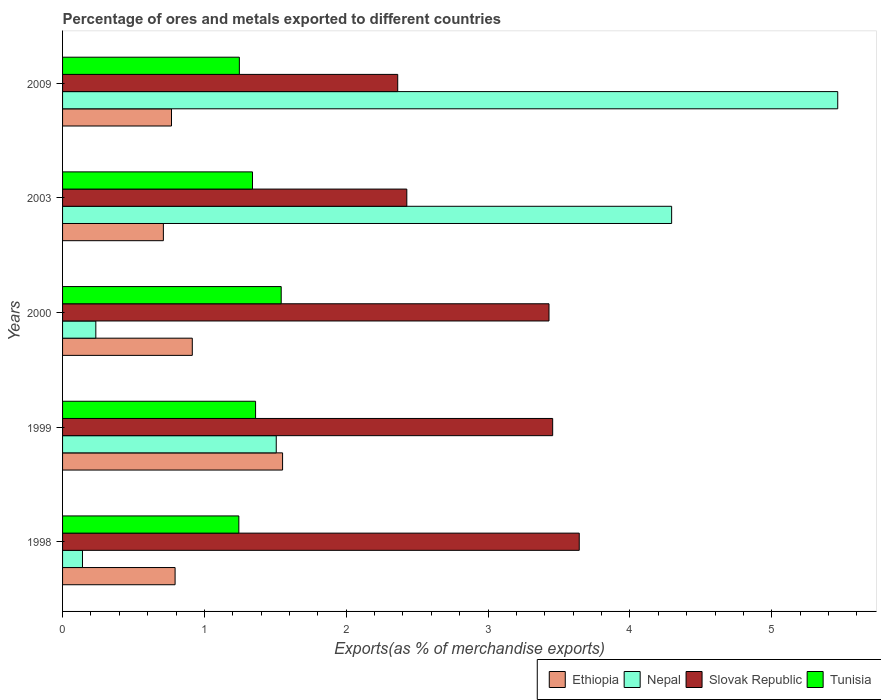How many different coloured bars are there?
Provide a short and direct response. 4. How many groups of bars are there?
Keep it short and to the point. 5. Are the number of bars per tick equal to the number of legend labels?
Ensure brevity in your answer.  Yes. Are the number of bars on each tick of the Y-axis equal?
Provide a succinct answer. Yes. How many bars are there on the 4th tick from the bottom?
Give a very brief answer. 4. In how many cases, is the number of bars for a given year not equal to the number of legend labels?
Provide a succinct answer. 0. What is the percentage of exports to different countries in Nepal in 2003?
Your response must be concise. 4.29. Across all years, what is the maximum percentage of exports to different countries in Ethiopia?
Your response must be concise. 1.55. Across all years, what is the minimum percentage of exports to different countries in Ethiopia?
Your answer should be compact. 0.71. What is the total percentage of exports to different countries in Nepal in the graph?
Provide a succinct answer. 11.64. What is the difference between the percentage of exports to different countries in Ethiopia in 1999 and that in 2003?
Make the answer very short. 0.84. What is the difference between the percentage of exports to different countries in Tunisia in 2009 and the percentage of exports to different countries in Nepal in 1998?
Your answer should be very brief. 1.11. What is the average percentage of exports to different countries in Tunisia per year?
Provide a succinct answer. 1.35. In the year 1998, what is the difference between the percentage of exports to different countries in Nepal and percentage of exports to different countries in Slovak Republic?
Keep it short and to the point. -3.5. What is the ratio of the percentage of exports to different countries in Tunisia in 1999 to that in 2000?
Offer a terse response. 0.88. Is the percentage of exports to different countries in Slovak Republic in 2003 less than that in 2009?
Provide a succinct answer. No. What is the difference between the highest and the second highest percentage of exports to different countries in Tunisia?
Your response must be concise. 0.18. What is the difference between the highest and the lowest percentage of exports to different countries in Tunisia?
Your answer should be very brief. 0.3. What does the 4th bar from the top in 2000 represents?
Make the answer very short. Ethiopia. What does the 4th bar from the bottom in 2003 represents?
Provide a succinct answer. Tunisia. Is it the case that in every year, the sum of the percentage of exports to different countries in Nepal and percentage of exports to different countries in Tunisia is greater than the percentage of exports to different countries in Ethiopia?
Your answer should be very brief. Yes. How many bars are there?
Ensure brevity in your answer.  20. How many years are there in the graph?
Keep it short and to the point. 5. Are the values on the major ticks of X-axis written in scientific E-notation?
Ensure brevity in your answer.  No. Does the graph contain any zero values?
Give a very brief answer. No. Where does the legend appear in the graph?
Ensure brevity in your answer.  Bottom right. How many legend labels are there?
Your answer should be compact. 4. What is the title of the graph?
Give a very brief answer. Percentage of ores and metals exported to different countries. Does "Upper middle income" appear as one of the legend labels in the graph?
Offer a very short reply. No. What is the label or title of the X-axis?
Offer a terse response. Exports(as % of merchandise exports). What is the label or title of the Y-axis?
Give a very brief answer. Years. What is the Exports(as % of merchandise exports) of Ethiopia in 1998?
Provide a short and direct response. 0.79. What is the Exports(as % of merchandise exports) in Nepal in 1998?
Your response must be concise. 0.14. What is the Exports(as % of merchandise exports) in Slovak Republic in 1998?
Offer a very short reply. 3.64. What is the Exports(as % of merchandise exports) of Tunisia in 1998?
Give a very brief answer. 1.24. What is the Exports(as % of merchandise exports) in Ethiopia in 1999?
Provide a short and direct response. 1.55. What is the Exports(as % of merchandise exports) in Nepal in 1999?
Keep it short and to the point. 1.51. What is the Exports(as % of merchandise exports) in Slovak Republic in 1999?
Provide a succinct answer. 3.46. What is the Exports(as % of merchandise exports) in Tunisia in 1999?
Ensure brevity in your answer.  1.36. What is the Exports(as % of merchandise exports) in Ethiopia in 2000?
Your answer should be very brief. 0.91. What is the Exports(as % of merchandise exports) of Nepal in 2000?
Keep it short and to the point. 0.23. What is the Exports(as % of merchandise exports) in Slovak Republic in 2000?
Your answer should be compact. 3.43. What is the Exports(as % of merchandise exports) of Tunisia in 2000?
Your answer should be very brief. 1.54. What is the Exports(as % of merchandise exports) of Ethiopia in 2003?
Offer a very short reply. 0.71. What is the Exports(as % of merchandise exports) in Nepal in 2003?
Your answer should be compact. 4.29. What is the Exports(as % of merchandise exports) in Slovak Republic in 2003?
Your answer should be very brief. 2.43. What is the Exports(as % of merchandise exports) in Tunisia in 2003?
Make the answer very short. 1.34. What is the Exports(as % of merchandise exports) of Ethiopia in 2009?
Ensure brevity in your answer.  0.77. What is the Exports(as % of merchandise exports) of Nepal in 2009?
Ensure brevity in your answer.  5.47. What is the Exports(as % of merchandise exports) of Slovak Republic in 2009?
Give a very brief answer. 2.36. What is the Exports(as % of merchandise exports) in Tunisia in 2009?
Your answer should be compact. 1.25. Across all years, what is the maximum Exports(as % of merchandise exports) in Ethiopia?
Provide a succinct answer. 1.55. Across all years, what is the maximum Exports(as % of merchandise exports) in Nepal?
Your response must be concise. 5.47. Across all years, what is the maximum Exports(as % of merchandise exports) of Slovak Republic?
Your answer should be compact. 3.64. Across all years, what is the maximum Exports(as % of merchandise exports) in Tunisia?
Provide a short and direct response. 1.54. Across all years, what is the minimum Exports(as % of merchandise exports) in Ethiopia?
Your answer should be compact. 0.71. Across all years, what is the minimum Exports(as % of merchandise exports) of Nepal?
Offer a very short reply. 0.14. Across all years, what is the minimum Exports(as % of merchandise exports) in Slovak Republic?
Provide a short and direct response. 2.36. Across all years, what is the minimum Exports(as % of merchandise exports) of Tunisia?
Keep it short and to the point. 1.24. What is the total Exports(as % of merchandise exports) in Ethiopia in the graph?
Provide a succinct answer. 4.74. What is the total Exports(as % of merchandise exports) of Nepal in the graph?
Keep it short and to the point. 11.64. What is the total Exports(as % of merchandise exports) of Slovak Republic in the graph?
Keep it short and to the point. 15.32. What is the total Exports(as % of merchandise exports) in Tunisia in the graph?
Your answer should be very brief. 6.73. What is the difference between the Exports(as % of merchandise exports) of Ethiopia in 1998 and that in 1999?
Offer a terse response. -0.76. What is the difference between the Exports(as % of merchandise exports) in Nepal in 1998 and that in 1999?
Provide a succinct answer. -1.37. What is the difference between the Exports(as % of merchandise exports) of Slovak Republic in 1998 and that in 1999?
Your answer should be very brief. 0.19. What is the difference between the Exports(as % of merchandise exports) in Tunisia in 1998 and that in 1999?
Make the answer very short. -0.12. What is the difference between the Exports(as % of merchandise exports) of Ethiopia in 1998 and that in 2000?
Your answer should be very brief. -0.12. What is the difference between the Exports(as % of merchandise exports) in Nepal in 1998 and that in 2000?
Provide a short and direct response. -0.09. What is the difference between the Exports(as % of merchandise exports) of Slovak Republic in 1998 and that in 2000?
Give a very brief answer. 0.21. What is the difference between the Exports(as % of merchandise exports) of Tunisia in 1998 and that in 2000?
Your answer should be very brief. -0.3. What is the difference between the Exports(as % of merchandise exports) of Ethiopia in 1998 and that in 2003?
Your answer should be compact. 0.08. What is the difference between the Exports(as % of merchandise exports) of Nepal in 1998 and that in 2003?
Keep it short and to the point. -4.15. What is the difference between the Exports(as % of merchandise exports) of Slovak Republic in 1998 and that in 2003?
Make the answer very short. 1.22. What is the difference between the Exports(as % of merchandise exports) of Tunisia in 1998 and that in 2003?
Your answer should be compact. -0.1. What is the difference between the Exports(as % of merchandise exports) in Ethiopia in 1998 and that in 2009?
Your response must be concise. 0.03. What is the difference between the Exports(as % of merchandise exports) of Nepal in 1998 and that in 2009?
Make the answer very short. -5.32. What is the difference between the Exports(as % of merchandise exports) in Slovak Republic in 1998 and that in 2009?
Provide a short and direct response. 1.28. What is the difference between the Exports(as % of merchandise exports) of Tunisia in 1998 and that in 2009?
Make the answer very short. -0. What is the difference between the Exports(as % of merchandise exports) of Ethiopia in 1999 and that in 2000?
Give a very brief answer. 0.64. What is the difference between the Exports(as % of merchandise exports) of Nepal in 1999 and that in 2000?
Provide a short and direct response. 1.27. What is the difference between the Exports(as % of merchandise exports) of Slovak Republic in 1999 and that in 2000?
Keep it short and to the point. 0.03. What is the difference between the Exports(as % of merchandise exports) of Tunisia in 1999 and that in 2000?
Ensure brevity in your answer.  -0.18. What is the difference between the Exports(as % of merchandise exports) of Ethiopia in 1999 and that in 2003?
Your response must be concise. 0.84. What is the difference between the Exports(as % of merchandise exports) in Nepal in 1999 and that in 2003?
Offer a terse response. -2.79. What is the difference between the Exports(as % of merchandise exports) in Slovak Republic in 1999 and that in 2003?
Ensure brevity in your answer.  1.03. What is the difference between the Exports(as % of merchandise exports) of Tunisia in 1999 and that in 2003?
Your answer should be very brief. 0.02. What is the difference between the Exports(as % of merchandise exports) in Ethiopia in 1999 and that in 2009?
Your answer should be compact. 0.78. What is the difference between the Exports(as % of merchandise exports) of Nepal in 1999 and that in 2009?
Your answer should be very brief. -3.96. What is the difference between the Exports(as % of merchandise exports) of Slovak Republic in 1999 and that in 2009?
Offer a very short reply. 1.09. What is the difference between the Exports(as % of merchandise exports) in Tunisia in 1999 and that in 2009?
Ensure brevity in your answer.  0.11. What is the difference between the Exports(as % of merchandise exports) of Ethiopia in 2000 and that in 2003?
Keep it short and to the point. 0.2. What is the difference between the Exports(as % of merchandise exports) in Nepal in 2000 and that in 2003?
Your answer should be compact. -4.06. What is the difference between the Exports(as % of merchandise exports) in Slovak Republic in 2000 and that in 2003?
Provide a succinct answer. 1. What is the difference between the Exports(as % of merchandise exports) of Tunisia in 2000 and that in 2003?
Give a very brief answer. 0.2. What is the difference between the Exports(as % of merchandise exports) in Ethiopia in 2000 and that in 2009?
Offer a very short reply. 0.15. What is the difference between the Exports(as % of merchandise exports) in Nepal in 2000 and that in 2009?
Keep it short and to the point. -5.23. What is the difference between the Exports(as % of merchandise exports) of Slovak Republic in 2000 and that in 2009?
Provide a succinct answer. 1.07. What is the difference between the Exports(as % of merchandise exports) in Tunisia in 2000 and that in 2009?
Provide a succinct answer. 0.3. What is the difference between the Exports(as % of merchandise exports) of Ethiopia in 2003 and that in 2009?
Offer a very short reply. -0.06. What is the difference between the Exports(as % of merchandise exports) in Nepal in 2003 and that in 2009?
Provide a succinct answer. -1.17. What is the difference between the Exports(as % of merchandise exports) of Slovak Republic in 2003 and that in 2009?
Provide a short and direct response. 0.06. What is the difference between the Exports(as % of merchandise exports) of Tunisia in 2003 and that in 2009?
Offer a terse response. 0.09. What is the difference between the Exports(as % of merchandise exports) of Ethiopia in 1998 and the Exports(as % of merchandise exports) of Nepal in 1999?
Offer a terse response. -0.71. What is the difference between the Exports(as % of merchandise exports) in Ethiopia in 1998 and the Exports(as % of merchandise exports) in Slovak Republic in 1999?
Your answer should be compact. -2.66. What is the difference between the Exports(as % of merchandise exports) of Ethiopia in 1998 and the Exports(as % of merchandise exports) of Tunisia in 1999?
Your response must be concise. -0.57. What is the difference between the Exports(as % of merchandise exports) in Nepal in 1998 and the Exports(as % of merchandise exports) in Slovak Republic in 1999?
Keep it short and to the point. -3.31. What is the difference between the Exports(as % of merchandise exports) in Nepal in 1998 and the Exports(as % of merchandise exports) in Tunisia in 1999?
Provide a succinct answer. -1.22. What is the difference between the Exports(as % of merchandise exports) of Slovak Republic in 1998 and the Exports(as % of merchandise exports) of Tunisia in 1999?
Keep it short and to the point. 2.28. What is the difference between the Exports(as % of merchandise exports) of Ethiopia in 1998 and the Exports(as % of merchandise exports) of Nepal in 2000?
Give a very brief answer. 0.56. What is the difference between the Exports(as % of merchandise exports) in Ethiopia in 1998 and the Exports(as % of merchandise exports) in Slovak Republic in 2000?
Provide a short and direct response. -2.64. What is the difference between the Exports(as % of merchandise exports) of Ethiopia in 1998 and the Exports(as % of merchandise exports) of Tunisia in 2000?
Provide a short and direct response. -0.75. What is the difference between the Exports(as % of merchandise exports) of Nepal in 1998 and the Exports(as % of merchandise exports) of Slovak Republic in 2000?
Provide a short and direct response. -3.29. What is the difference between the Exports(as % of merchandise exports) in Nepal in 1998 and the Exports(as % of merchandise exports) in Tunisia in 2000?
Your answer should be compact. -1.4. What is the difference between the Exports(as % of merchandise exports) of Slovak Republic in 1998 and the Exports(as % of merchandise exports) of Tunisia in 2000?
Offer a terse response. 2.1. What is the difference between the Exports(as % of merchandise exports) of Ethiopia in 1998 and the Exports(as % of merchandise exports) of Nepal in 2003?
Give a very brief answer. -3.5. What is the difference between the Exports(as % of merchandise exports) in Ethiopia in 1998 and the Exports(as % of merchandise exports) in Slovak Republic in 2003?
Your response must be concise. -1.63. What is the difference between the Exports(as % of merchandise exports) of Ethiopia in 1998 and the Exports(as % of merchandise exports) of Tunisia in 2003?
Provide a succinct answer. -0.55. What is the difference between the Exports(as % of merchandise exports) of Nepal in 1998 and the Exports(as % of merchandise exports) of Slovak Republic in 2003?
Give a very brief answer. -2.29. What is the difference between the Exports(as % of merchandise exports) in Nepal in 1998 and the Exports(as % of merchandise exports) in Tunisia in 2003?
Offer a terse response. -1.2. What is the difference between the Exports(as % of merchandise exports) of Slovak Republic in 1998 and the Exports(as % of merchandise exports) of Tunisia in 2003?
Give a very brief answer. 2.3. What is the difference between the Exports(as % of merchandise exports) in Ethiopia in 1998 and the Exports(as % of merchandise exports) in Nepal in 2009?
Provide a succinct answer. -4.67. What is the difference between the Exports(as % of merchandise exports) in Ethiopia in 1998 and the Exports(as % of merchandise exports) in Slovak Republic in 2009?
Keep it short and to the point. -1.57. What is the difference between the Exports(as % of merchandise exports) in Ethiopia in 1998 and the Exports(as % of merchandise exports) in Tunisia in 2009?
Your response must be concise. -0.45. What is the difference between the Exports(as % of merchandise exports) of Nepal in 1998 and the Exports(as % of merchandise exports) of Slovak Republic in 2009?
Provide a short and direct response. -2.22. What is the difference between the Exports(as % of merchandise exports) of Nepal in 1998 and the Exports(as % of merchandise exports) of Tunisia in 2009?
Make the answer very short. -1.11. What is the difference between the Exports(as % of merchandise exports) of Slovak Republic in 1998 and the Exports(as % of merchandise exports) of Tunisia in 2009?
Provide a succinct answer. 2.4. What is the difference between the Exports(as % of merchandise exports) in Ethiopia in 1999 and the Exports(as % of merchandise exports) in Nepal in 2000?
Provide a succinct answer. 1.32. What is the difference between the Exports(as % of merchandise exports) of Ethiopia in 1999 and the Exports(as % of merchandise exports) of Slovak Republic in 2000?
Keep it short and to the point. -1.88. What is the difference between the Exports(as % of merchandise exports) in Ethiopia in 1999 and the Exports(as % of merchandise exports) in Tunisia in 2000?
Your response must be concise. 0.01. What is the difference between the Exports(as % of merchandise exports) of Nepal in 1999 and the Exports(as % of merchandise exports) of Slovak Republic in 2000?
Provide a succinct answer. -1.92. What is the difference between the Exports(as % of merchandise exports) in Nepal in 1999 and the Exports(as % of merchandise exports) in Tunisia in 2000?
Keep it short and to the point. -0.04. What is the difference between the Exports(as % of merchandise exports) of Slovak Republic in 1999 and the Exports(as % of merchandise exports) of Tunisia in 2000?
Keep it short and to the point. 1.91. What is the difference between the Exports(as % of merchandise exports) of Ethiopia in 1999 and the Exports(as % of merchandise exports) of Nepal in 2003?
Provide a succinct answer. -2.74. What is the difference between the Exports(as % of merchandise exports) of Ethiopia in 1999 and the Exports(as % of merchandise exports) of Slovak Republic in 2003?
Ensure brevity in your answer.  -0.88. What is the difference between the Exports(as % of merchandise exports) in Ethiopia in 1999 and the Exports(as % of merchandise exports) in Tunisia in 2003?
Give a very brief answer. 0.21. What is the difference between the Exports(as % of merchandise exports) in Nepal in 1999 and the Exports(as % of merchandise exports) in Slovak Republic in 2003?
Give a very brief answer. -0.92. What is the difference between the Exports(as % of merchandise exports) in Nepal in 1999 and the Exports(as % of merchandise exports) in Tunisia in 2003?
Ensure brevity in your answer.  0.17. What is the difference between the Exports(as % of merchandise exports) in Slovak Republic in 1999 and the Exports(as % of merchandise exports) in Tunisia in 2003?
Offer a terse response. 2.12. What is the difference between the Exports(as % of merchandise exports) of Ethiopia in 1999 and the Exports(as % of merchandise exports) of Nepal in 2009?
Give a very brief answer. -3.91. What is the difference between the Exports(as % of merchandise exports) of Ethiopia in 1999 and the Exports(as % of merchandise exports) of Slovak Republic in 2009?
Your answer should be compact. -0.81. What is the difference between the Exports(as % of merchandise exports) in Ethiopia in 1999 and the Exports(as % of merchandise exports) in Tunisia in 2009?
Offer a terse response. 0.3. What is the difference between the Exports(as % of merchandise exports) of Nepal in 1999 and the Exports(as % of merchandise exports) of Slovak Republic in 2009?
Offer a terse response. -0.86. What is the difference between the Exports(as % of merchandise exports) in Nepal in 1999 and the Exports(as % of merchandise exports) in Tunisia in 2009?
Provide a succinct answer. 0.26. What is the difference between the Exports(as % of merchandise exports) in Slovak Republic in 1999 and the Exports(as % of merchandise exports) in Tunisia in 2009?
Provide a succinct answer. 2.21. What is the difference between the Exports(as % of merchandise exports) of Ethiopia in 2000 and the Exports(as % of merchandise exports) of Nepal in 2003?
Make the answer very short. -3.38. What is the difference between the Exports(as % of merchandise exports) of Ethiopia in 2000 and the Exports(as % of merchandise exports) of Slovak Republic in 2003?
Your response must be concise. -1.51. What is the difference between the Exports(as % of merchandise exports) of Ethiopia in 2000 and the Exports(as % of merchandise exports) of Tunisia in 2003?
Give a very brief answer. -0.42. What is the difference between the Exports(as % of merchandise exports) in Nepal in 2000 and the Exports(as % of merchandise exports) in Slovak Republic in 2003?
Make the answer very short. -2.19. What is the difference between the Exports(as % of merchandise exports) of Nepal in 2000 and the Exports(as % of merchandise exports) of Tunisia in 2003?
Ensure brevity in your answer.  -1.1. What is the difference between the Exports(as % of merchandise exports) in Slovak Republic in 2000 and the Exports(as % of merchandise exports) in Tunisia in 2003?
Your response must be concise. 2.09. What is the difference between the Exports(as % of merchandise exports) in Ethiopia in 2000 and the Exports(as % of merchandise exports) in Nepal in 2009?
Your response must be concise. -4.55. What is the difference between the Exports(as % of merchandise exports) in Ethiopia in 2000 and the Exports(as % of merchandise exports) in Slovak Republic in 2009?
Ensure brevity in your answer.  -1.45. What is the difference between the Exports(as % of merchandise exports) of Ethiopia in 2000 and the Exports(as % of merchandise exports) of Tunisia in 2009?
Offer a terse response. -0.33. What is the difference between the Exports(as % of merchandise exports) of Nepal in 2000 and the Exports(as % of merchandise exports) of Slovak Republic in 2009?
Provide a short and direct response. -2.13. What is the difference between the Exports(as % of merchandise exports) in Nepal in 2000 and the Exports(as % of merchandise exports) in Tunisia in 2009?
Give a very brief answer. -1.01. What is the difference between the Exports(as % of merchandise exports) in Slovak Republic in 2000 and the Exports(as % of merchandise exports) in Tunisia in 2009?
Provide a short and direct response. 2.18. What is the difference between the Exports(as % of merchandise exports) of Ethiopia in 2003 and the Exports(as % of merchandise exports) of Nepal in 2009?
Your answer should be very brief. -4.75. What is the difference between the Exports(as % of merchandise exports) of Ethiopia in 2003 and the Exports(as % of merchandise exports) of Slovak Republic in 2009?
Offer a terse response. -1.65. What is the difference between the Exports(as % of merchandise exports) in Ethiopia in 2003 and the Exports(as % of merchandise exports) in Tunisia in 2009?
Offer a terse response. -0.54. What is the difference between the Exports(as % of merchandise exports) in Nepal in 2003 and the Exports(as % of merchandise exports) in Slovak Republic in 2009?
Your response must be concise. 1.93. What is the difference between the Exports(as % of merchandise exports) of Nepal in 2003 and the Exports(as % of merchandise exports) of Tunisia in 2009?
Your response must be concise. 3.05. What is the difference between the Exports(as % of merchandise exports) of Slovak Republic in 2003 and the Exports(as % of merchandise exports) of Tunisia in 2009?
Ensure brevity in your answer.  1.18. What is the average Exports(as % of merchandise exports) in Ethiopia per year?
Provide a short and direct response. 0.95. What is the average Exports(as % of merchandise exports) of Nepal per year?
Ensure brevity in your answer.  2.33. What is the average Exports(as % of merchandise exports) in Slovak Republic per year?
Offer a terse response. 3.06. What is the average Exports(as % of merchandise exports) in Tunisia per year?
Give a very brief answer. 1.35. In the year 1998, what is the difference between the Exports(as % of merchandise exports) in Ethiopia and Exports(as % of merchandise exports) in Nepal?
Your response must be concise. 0.65. In the year 1998, what is the difference between the Exports(as % of merchandise exports) in Ethiopia and Exports(as % of merchandise exports) in Slovak Republic?
Make the answer very short. -2.85. In the year 1998, what is the difference between the Exports(as % of merchandise exports) in Ethiopia and Exports(as % of merchandise exports) in Tunisia?
Provide a short and direct response. -0.45. In the year 1998, what is the difference between the Exports(as % of merchandise exports) of Nepal and Exports(as % of merchandise exports) of Slovak Republic?
Offer a very short reply. -3.5. In the year 1998, what is the difference between the Exports(as % of merchandise exports) of Nepal and Exports(as % of merchandise exports) of Tunisia?
Offer a very short reply. -1.1. In the year 1998, what is the difference between the Exports(as % of merchandise exports) of Slovak Republic and Exports(as % of merchandise exports) of Tunisia?
Provide a succinct answer. 2.4. In the year 1999, what is the difference between the Exports(as % of merchandise exports) of Ethiopia and Exports(as % of merchandise exports) of Nepal?
Ensure brevity in your answer.  0.04. In the year 1999, what is the difference between the Exports(as % of merchandise exports) of Ethiopia and Exports(as % of merchandise exports) of Slovak Republic?
Offer a very short reply. -1.9. In the year 1999, what is the difference between the Exports(as % of merchandise exports) of Ethiopia and Exports(as % of merchandise exports) of Tunisia?
Ensure brevity in your answer.  0.19. In the year 1999, what is the difference between the Exports(as % of merchandise exports) in Nepal and Exports(as % of merchandise exports) in Slovak Republic?
Provide a short and direct response. -1.95. In the year 1999, what is the difference between the Exports(as % of merchandise exports) of Nepal and Exports(as % of merchandise exports) of Tunisia?
Provide a short and direct response. 0.15. In the year 1999, what is the difference between the Exports(as % of merchandise exports) in Slovak Republic and Exports(as % of merchandise exports) in Tunisia?
Your response must be concise. 2.09. In the year 2000, what is the difference between the Exports(as % of merchandise exports) in Ethiopia and Exports(as % of merchandise exports) in Nepal?
Give a very brief answer. 0.68. In the year 2000, what is the difference between the Exports(as % of merchandise exports) in Ethiopia and Exports(as % of merchandise exports) in Slovak Republic?
Give a very brief answer. -2.51. In the year 2000, what is the difference between the Exports(as % of merchandise exports) in Ethiopia and Exports(as % of merchandise exports) in Tunisia?
Your answer should be very brief. -0.63. In the year 2000, what is the difference between the Exports(as % of merchandise exports) of Nepal and Exports(as % of merchandise exports) of Slovak Republic?
Your answer should be compact. -3.2. In the year 2000, what is the difference between the Exports(as % of merchandise exports) of Nepal and Exports(as % of merchandise exports) of Tunisia?
Provide a short and direct response. -1.31. In the year 2000, what is the difference between the Exports(as % of merchandise exports) in Slovak Republic and Exports(as % of merchandise exports) in Tunisia?
Give a very brief answer. 1.89. In the year 2003, what is the difference between the Exports(as % of merchandise exports) in Ethiopia and Exports(as % of merchandise exports) in Nepal?
Offer a terse response. -3.58. In the year 2003, what is the difference between the Exports(as % of merchandise exports) of Ethiopia and Exports(as % of merchandise exports) of Slovak Republic?
Keep it short and to the point. -1.72. In the year 2003, what is the difference between the Exports(as % of merchandise exports) of Ethiopia and Exports(as % of merchandise exports) of Tunisia?
Your answer should be compact. -0.63. In the year 2003, what is the difference between the Exports(as % of merchandise exports) in Nepal and Exports(as % of merchandise exports) in Slovak Republic?
Your answer should be compact. 1.87. In the year 2003, what is the difference between the Exports(as % of merchandise exports) in Nepal and Exports(as % of merchandise exports) in Tunisia?
Keep it short and to the point. 2.96. In the year 2003, what is the difference between the Exports(as % of merchandise exports) in Slovak Republic and Exports(as % of merchandise exports) in Tunisia?
Make the answer very short. 1.09. In the year 2009, what is the difference between the Exports(as % of merchandise exports) in Ethiopia and Exports(as % of merchandise exports) in Nepal?
Offer a terse response. -4.7. In the year 2009, what is the difference between the Exports(as % of merchandise exports) in Ethiopia and Exports(as % of merchandise exports) in Slovak Republic?
Your answer should be very brief. -1.59. In the year 2009, what is the difference between the Exports(as % of merchandise exports) of Ethiopia and Exports(as % of merchandise exports) of Tunisia?
Give a very brief answer. -0.48. In the year 2009, what is the difference between the Exports(as % of merchandise exports) of Nepal and Exports(as % of merchandise exports) of Slovak Republic?
Ensure brevity in your answer.  3.1. In the year 2009, what is the difference between the Exports(as % of merchandise exports) of Nepal and Exports(as % of merchandise exports) of Tunisia?
Keep it short and to the point. 4.22. In the year 2009, what is the difference between the Exports(as % of merchandise exports) in Slovak Republic and Exports(as % of merchandise exports) in Tunisia?
Provide a succinct answer. 1.12. What is the ratio of the Exports(as % of merchandise exports) in Ethiopia in 1998 to that in 1999?
Ensure brevity in your answer.  0.51. What is the ratio of the Exports(as % of merchandise exports) in Nepal in 1998 to that in 1999?
Your response must be concise. 0.09. What is the ratio of the Exports(as % of merchandise exports) in Slovak Republic in 1998 to that in 1999?
Provide a short and direct response. 1.05. What is the ratio of the Exports(as % of merchandise exports) of Tunisia in 1998 to that in 1999?
Offer a terse response. 0.91. What is the ratio of the Exports(as % of merchandise exports) of Ethiopia in 1998 to that in 2000?
Give a very brief answer. 0.87. What is the ratio of the Exports(as % of merchandise exports) in Nepal in 1998 to that in 2000?
Provide a succinct answer. 0.6. What is the ratio of the Exports(as % of merchandise exports) in Slovak Republic in 1998 to that in 2000?
Your answer should be compact. 1.06. What is the ratio of the Exports(as % of merchandise exports) of Tunisia in 1998 to that in 2000?
Offer a very short reply. 0.81. What is the ratio of the Exports(as % of merchandise exports) in Ethiopia in 1998 to that in 2003?
Keep it short and to the point. 1.12. What is the ratio of the Exports(as % of merchandise exports) of Nepal in 1998 to that in 2003?
Your answer should be very brief. 0.03. What is the ratio of the Exports(as % of merchandise exports) of Slovak Republic in 1998 to that in 2003?
Keep it short and to the point. 1.5. What is the ratio of the Exports(as % of merchandise exports) of Tunisia in 1998 to that in 2003?
Offer a very short reply. 0.93. What is the ratio of the Exports(as % of merchandise exports) of Ethiopia in 1998 to that in 2009?
Your answer should be compact. 1.03. What is the ratio of the Exports(as % of merchandise exports) in Nepal in 1998 to that in 2009?
Give a very brief answer. 0.03. What is the ratio of the Exports(as % of merchandise exports) of Slovak Republic in 1998 to that in 2009?
Provide a short and direct response. 1.54. What is the ratio of the Exports(as % of merchandise exports) in Tunisia in 1998 to that in 2009?
Offer a terse response. 1. What is the ratio of the Exports(as % of merchandise exports) of Ethiopia in 1999 to that in 2000?
Keep it short and to the point. 1.7. What is the ratio of the Exports(as % of merchandise exports) of Nepal in 1999 to that in 2000?
Provide a succinct answer. 6.42. What is the ratio of the Exports(as % of merchandise exports) in Slovak Republic in 1999 to that in 2000?
Provide a short and direct response. 1.01. What is the ratio of the Exports(as % of merchandise exports) of Tunisia in 1999 to that in 2000?
Ensure brevity in your answer.  0.88. What is the ratio of the Exports(as % of merchandise exports) in Ethiopia in 1999 to that in 2003?
Make the answer very short. 2.18. What is the ratio of the Exports(as % of merchandise exports) of Nepal in 1999 to that in 2003?
Offer a very short reply. 0.35. What is the ratio of the Exports(as % of merchandise exports) in Slovak Republic in 1999 to that in 2003?
Your answer should be very brief. 1.42. What is the ratio of the Exports(as % of merchandise exports) of Tunisia in 1999 to that in 2003?
Your answer should be very brief. 1.02. What is the ratio of the Exports(as % of merchandise exports) of Ethiopia in 1999 to that in 2009?
Your answer should be very brief. 2.02. What is the ratio of the Exports(as % of merchandise exports) in Nepal in 1999 to that in 2009?
Your answer should be very brief. 0.28. What is the ratio of the Exports(as % of merchandise exports) in Slovak Republic in 1999 to that in 2009?
Offer a terse response. 1.46. What is the ratio of the Exports(as % of merchandise exports) in Tunisia in 1999 to that in 2009?
Make the answer very short. 1.09. What is the ratio of the Exports(as % of merchandise exports) of Ethiopia in 2000 to that in 2003?
Ensure brevity in your answer.  1.29. What is the ratio of the Exports(as % of merchandise exports) of Nepal in 2000 to that in 2003?
Make the answer very short. 0.05. What is the ratio of the Exports(as % of merchandise exports) of Slovak Republic in 2000 to that in 2003?
Make the answer very short. 1.41. What is the ratio of the Exports(as % of merchandise exports) of Tunisia in 2000 to that in 2003?
Give a very brief answer. 1.15. What is the ratio of the Exports(as % of merchandise exports) of Ethiopia in 2000 to that in 2009?
Your answer should be very brief. 1.19. What is the ratio of the Exports(as % of merchandise exports) in Nepal in 2000 to that in 2009?
Offer a terse response. 0.04. What is the ratio of the Exports(as % of merchandise exports) of Slovak Republic in 2000 to that in 2009?
Your answer should be compact. 1.45. What is the ratio of the Exports(as % of merchandise exports) in Tunisia in 2000 to that in 2009?
Your answer should be very brief. 1.24. What is the ratio of the Exports(as % of merchandise exports) of Ethiopia in 2003 to that in 2009?
Keep it short and to the point. 0.93. What is the ratio of the Exports(as % of merchandise exports) of Nepal in 2003 to that in 2009?
Give a very brief answer. 0.79. What is the ratio of the Exports(as % of merchandise exports) of Slovak Republic in 2003 to that in 2009?
Offer a very short reply. 1.03. What is the ratio of the Exports(as % of merchandise exports) of Tunisia in 2003 to that in 2009?
Provide a succinct answer. 1.07. What is the difference between the highest and the second highest Exports(as % of merchandise exports) of Ethiopia?
Make the answer very short. 0.64. What is the difference between the highest and the second highest Exports(as % of merchandise exports) in Nepal?
Provide a succinct answer. 1.17. What is the difference between the highest and the second highest Exports(as % of merchandise exports) in Slovak Republic?
Your answer should be compact. 0.19. What is the difference between the highest and the second highest Exports(as % of merchandise exports) of Tunisia?
Your answer should be very brief. 0.18. What is the difference between the highest and the lowest Exports(as % of merchandise exports) of Ethiopia?
Make the answer very short. 0.84. What is the difference between the highest and the lowest Exports(as % of merchandise exports) in Nepal?
Provide a short and direct response. 5.32. What is the difference between the highest and the lowest Exports(as % of merchandise exports) in Slovak Republic?
Offer a very short reply. 1.28. What is the difference between the highest and the lowest Exports(as % of merchandise exports) in Tunisia?
Your answer should be compact. 0.3. 